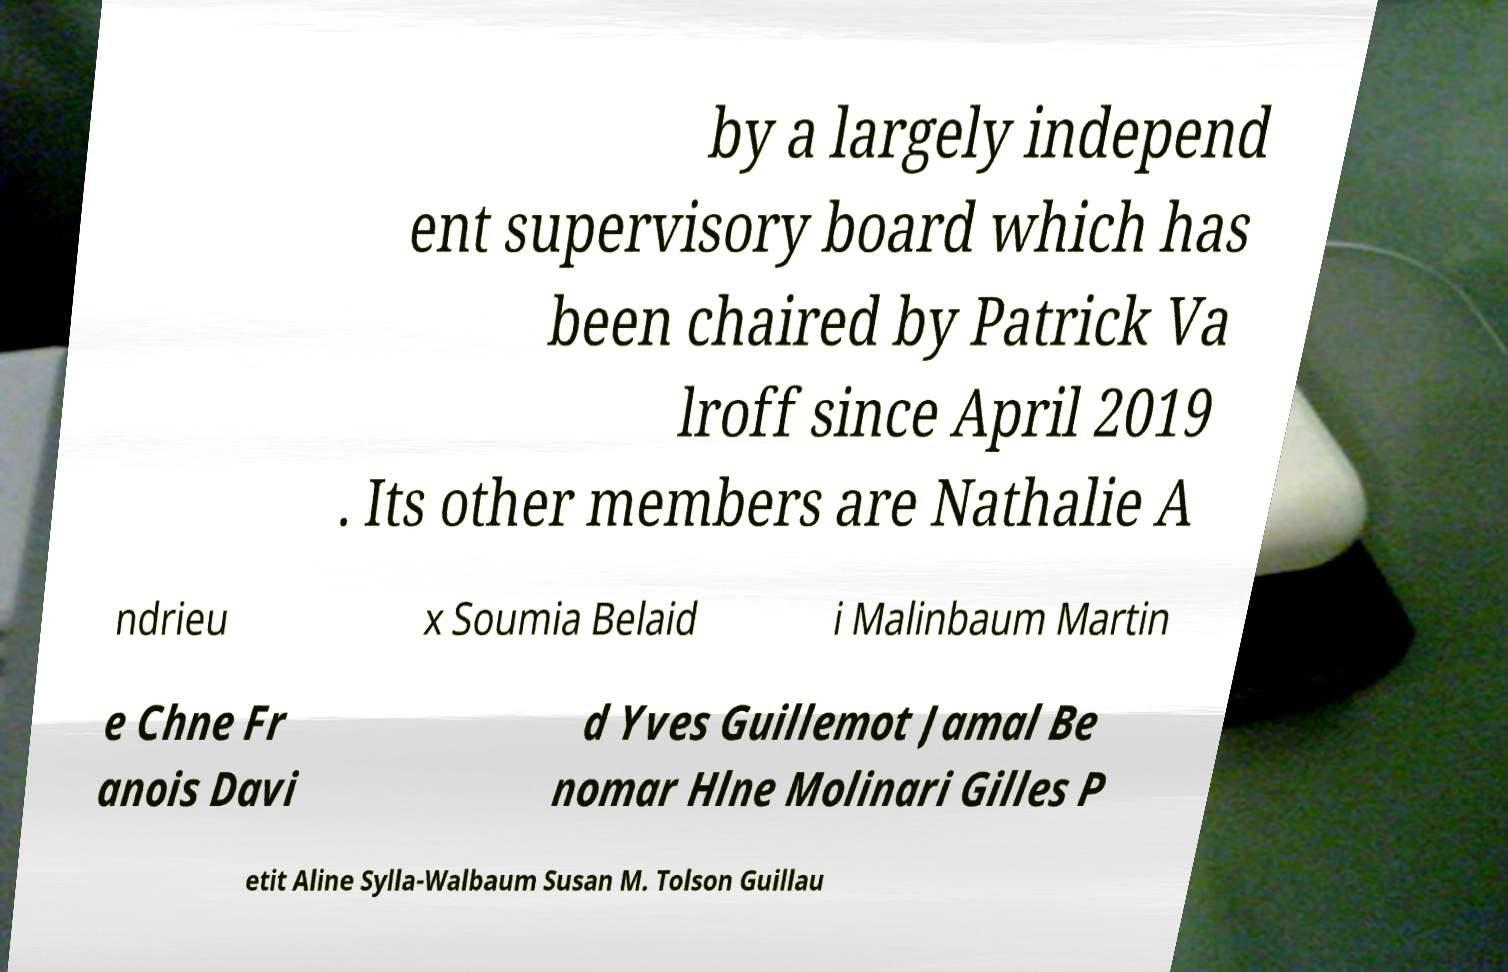Can you read and provide the text displayed in the image?This photo seems to have some interesting text. Can you extract and type it out for me? by a largely independ ent supervisory board which has been chaired by Patrick Va lroff since April 2019 . Its other members are Nathalie A ndrieu x Soumia Belaid i Malinbaum Martin e Chne Fr anois Davi d Yves Guillemot Jamal Be nomar Hlne Molinari Gilles P etit Aline Sylla-Walbaum Susan M. Tolson Guillau 